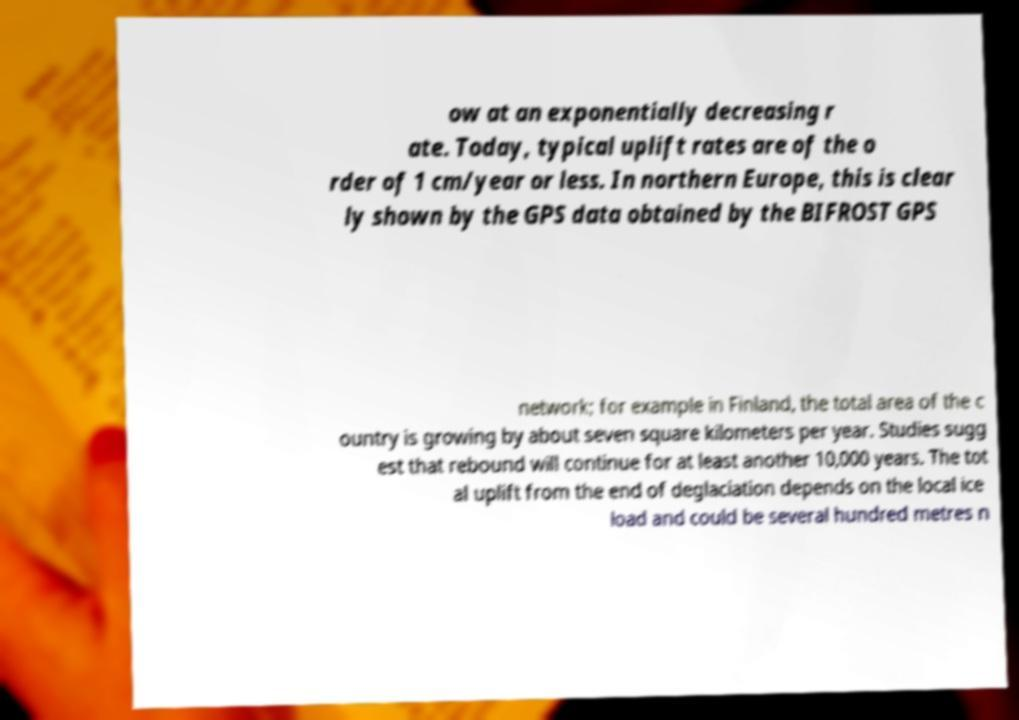Could you assist in decoding the text presented in this image and type it out clearly? ow at an exponentially decreasing r ate. Today, typical uplift rates are of the o rder of 1 cm/year or less. In northern Europe, this is clear ly shown by the GPS data obtained by the BIFROST GPS network; for example in Finland, the total area of the c ountry is growing by about seven square kilometers per year. Studies sugg est that rebound will continue for at least another 10,000 years. The tot al uplift from the end of deglaciation depends on the local ice load and could be several hundred metres n 